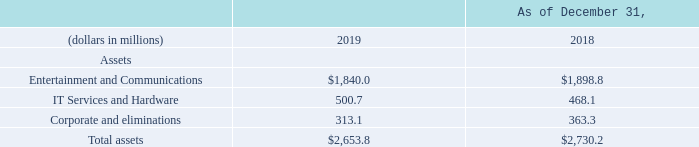Total assets for the Company decreased $76.4 million as of December 31, 2019 as compared to December 31, 2018.  Entertainment and Communications assets decreased $58.8 million due to a decrease in property, plant and equipment primarily as a result of the increased depreciation in 2019 related to Hawaiian Telcom property, plant and equipment exceeding capital expenditures. IT Services and Hardware assets increased by $32.6 million primarily due to the Company’s recognition of operating lease right-of-use assets in the Consolidated Balance Sheets upon adoption of ASU 2016-02.
Corporate assets decreased $50.2 million primarily due to decreased receivables. Lower receivables is partially due to timing of sales in the fourth quarter as well as additional sales of certain receivables under the factoring arrangement as of December 31, 2019 compared to December 31, 2018. Deferred tax assets and liabilities totaled $59.3 million and $11.7 million as of December 31, 2019, respectively. Deferred tax assets and liabilities totaled $47.5 million and $11.4 million as of December 31, 2018, respectively. The increase in deferred tax assets in 2019, as compared to 2018, is due to increased net operating losses in 2019.
What is the company's total assets as at December 31, 2019?
Answer scale should be: million. $2,653.8. What is the company's total assets as at December 31, 2018?
Answer scale should be: million. $2,730.2. What is the sum of company's total assets between 2018 to 2019?
Answer scale should be: million. $2,653.8  +$2,730.2
Answer: 5384. What is the company's 2019 assets under IT services and hardware?
Answer scale should be: million. 500.7. Which asset classification makes up the biggest proportion of the company's assets as at December 31, 2019? $1,840.0 is the biggest value
Answer: entertainment and communication. What is the change in the value of the company's total assets between 2018 and 2019?
Answer scale should be: million. $2,653.8 - $2,730.2 
Answer: -76.4. Why did Corporate assets decrease? Corporate assets decreased $50.2 million primarily due to decreased receivables. 